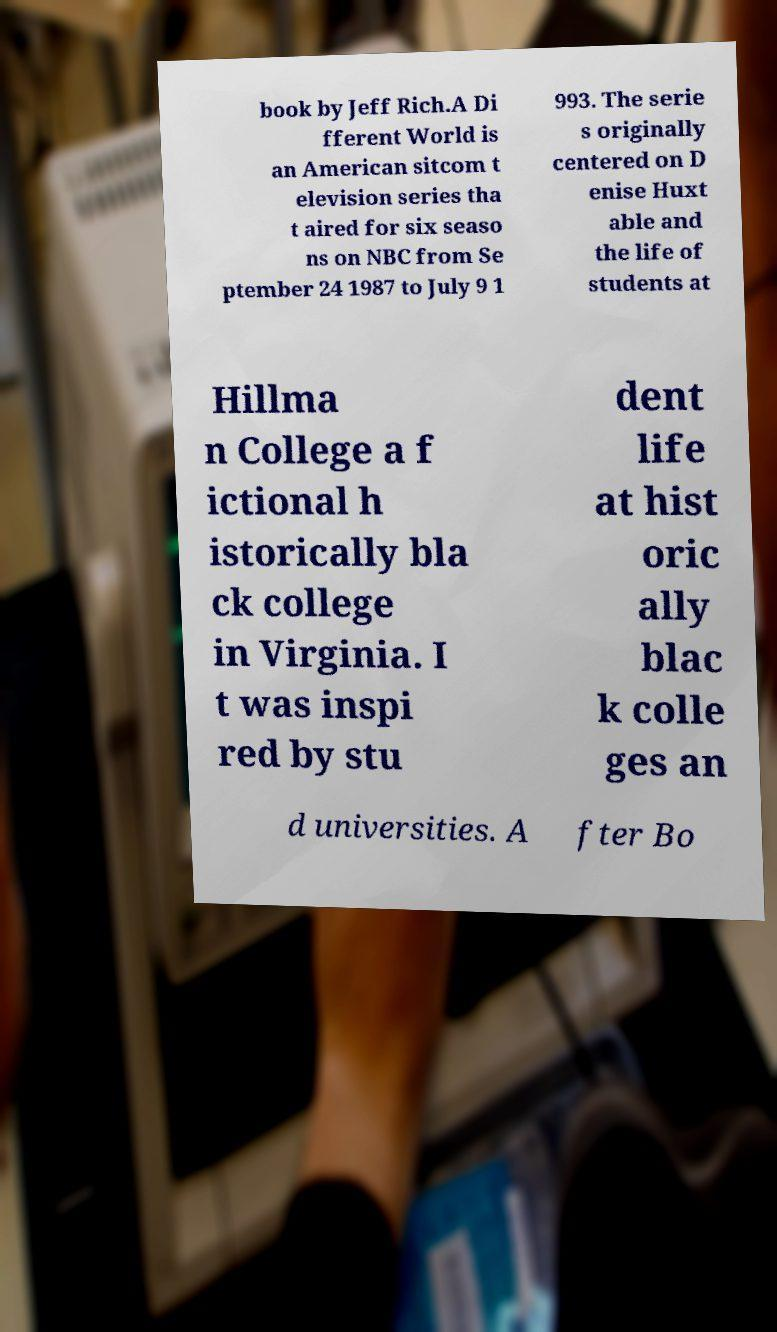For documentation purposes, I need the text within this image transcribed. Could you provide that? book by Jeff Rich.A Di fferent World is an American sitcom t elevision series tha t aired for six seaso ns on NBC from Se ptember 24 1987 to July 9 1 993. The serie s originally centered on D enise Huxt able and the life of students at Hillma n College a f ictional h istorically bla ck college in Virginia. I t was inspi red by stu dent life at hist oric ally blac k colle ges an d universities. A fter Bo 